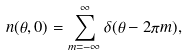Convert formula to latex. <formula><loc_0><loc_0><loc_500><loc_500>n ( \theta , 0 ) = \sum _ { m = - \infty } ^ { \infty } \delta ( \theta - 2 \pi m ) ,</formula> 